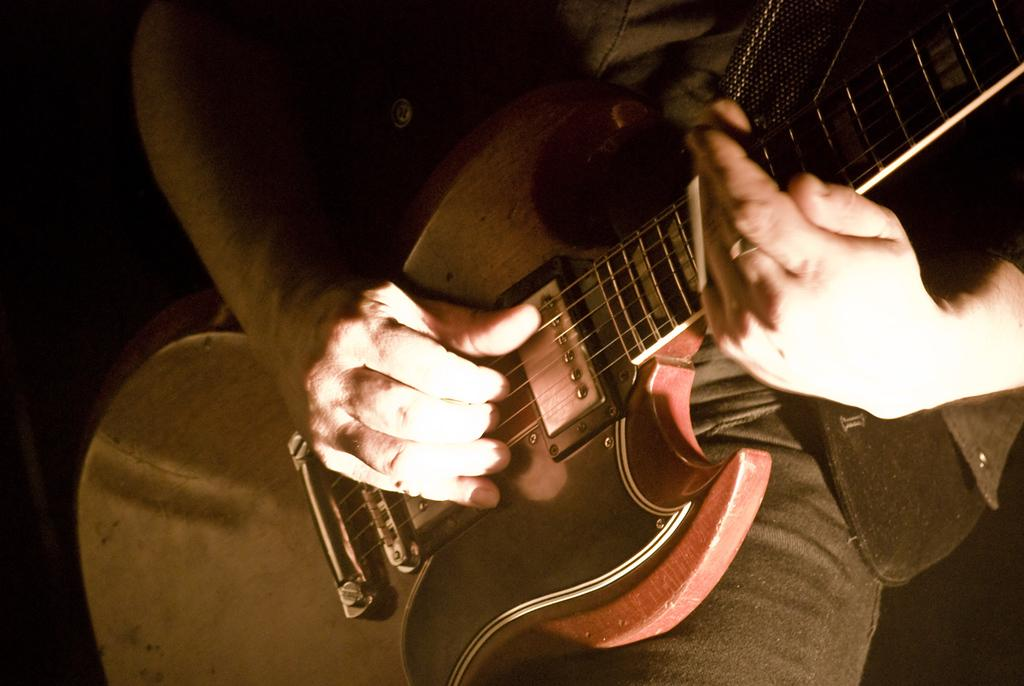What is the main subject of the image? There is a person in the image. What is the person holding in his hand? The person is holding a guitar in his hand. Is the person in the image trying to burn the guitar? There is no indication in the image that the person is trying to burn the guitar; he is simply holding it. 